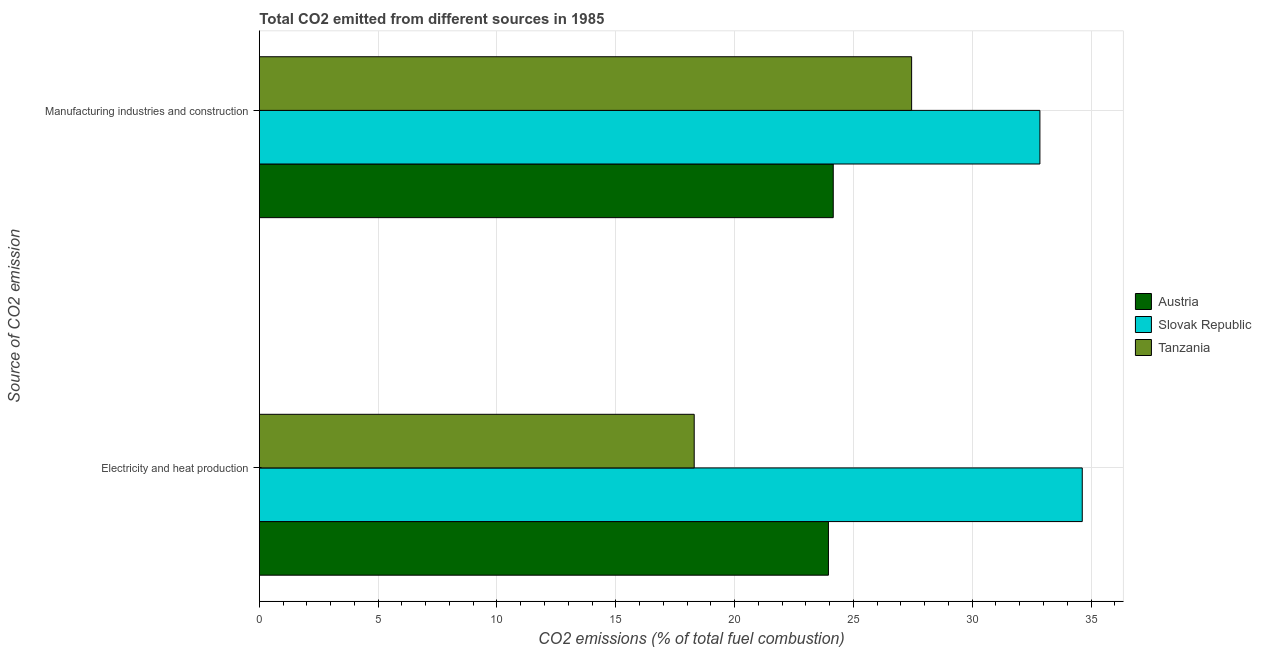How many different coloured bars are there?
Ensure brevity in your answer.  3. Are the number of bars per tick equal to the number of legend labels?
Offer a very short reply. Yes. Are the number of bars on each tick of the Y-axis equal?
Ensure brevity in your answer.  Yes. How many bars are there on the 1st tick from the top?
Offer a very short reply. 3. How many bars are there on the 2nd tick from the bottom?
Your response must be concise. 3. What is the label of the 1st group of bars from the top?
Make the answer very short. Manufacturing industries and construction. What is the co2 emissions due to manufacturing industries in Tanzania?
Your answer should be compact. 27.45. Across all countries, what is the maximum co2 emissions due to electricity and heat production?
Provide a succinct answer. 34.63. Across all countries, what is the minimum co2 emissions due to electricity and heat production?
Ensure brevity in your answer.  18.3. In which country was the co2 emissions due to electricity and heat production maximum?
Provide a short and direct response. Slovak Republic. In which country was the co2 emissions due to electricity and heat production minimum?
Your answer should be very brief. Tanzania. What is the total co2 emissions due to manufacturing industries in the graph?
Make the answer very short. 84.45. What is the difference between the co2 emissions due to electricity and heat production in Austria and that in Slovak Republic?
Offer a terse response. -10.68. What is the difference between the co2 emissions due to manufacturing industries in Tanzania and the co2 emissions due to electricity and heat production in Austria?
Make the answer very short. 3.5. What is the average co2 emissions due to electricity and heat production per country?
Offer a terse response. 25.63. What is the difference between the co2 emissions due to electricity and heat production and co2 emissions due to manufacturing industries in Slovak Republic?
Provide a short and direct response. 1.78. What is the ratio of the co2 emissions due to electricity and heat production in Slovak Republic to that in Austria?
Offer a terse response. 1.45. Is the co2 emissions due to electricity and heat production in Slovak Republic less than that in Tanzania?
Your answer should be very brief. No. In how many countries, is the co2 emissions due to electricity and heat production greater than the average co2 emissions due to electricity and heat production taken over all countries?
Offer a terse response. 1. What does the 3rd bar from the top in Manufacturing industries and construction represents?
Provide a short and direct response. Austria. What does the 3rd bar from the bottom in Manufacturing industries and construction represents?
Give a very brief answer. Tanzania. Are all the bars in the graph horizontal?
Your answer should be very brief. Yes. What is the difference between two consecutive major ticks on the X-axis?
Your response must be concise. 5. Where does the legend appear in the graph?
Offer a very short reply. Center right. How many legend labels are there?
Your answer should be compact. 3. What is the title of the graph?
Provide a short and direct response. Total CO2 emitted from different sources in 1985. Does "OECD members" appear as one of the legend labels in the graph?
Give a very brief answer. No. What is the label or title of the X-axis?
Offer a very short reply. CO2 emissions (% of total fuel combustion). What is the label or title of the Y-axis?
Ensure brevity in your answer.  Source of CO2 emission. What is the CO2 emissions (% of total fuel combustion) in Austria in Electricity and heat production?
Provide a short and direct response. 23.95. What is the CO2 emissions (% of total fuel combustion) of Slovak Republic in Electricity and heat production?
Offer a very short reply. 34.63. What is the CO2 emissions (% of total fuel combustion) of Tanzania in Electricity and heat production?
Your response must be concise. 18.3. What is the CO2 emissions (% of total fuel combustion) in Austria in Manufacturing industries and construction?
Your answer should be very brief. 24.15. What is the CO2 emissions (% of total fuel combustion) of Slovak Republic in Manufacturing industries and construction?
Your response must be concise. 32.85. What is the CO2 emissions (% of total fuel combustion) in Tanzania in Manufacturing industries and construction?
Your answer should be compact. 27.45. Across all Source of CO2 emission, what is the maximum CO2 emissions (% of total fuel combustion) in Austria?
Give a very brief answer. 24.15. Across all Source of CO2 emission, what is the maximum CO2 emissions (% of total fuel combustion) in Slovak Republic?
Your answer should be compact. 34.63. Across all Source of CO2 emission, what is the maximum CO2 emissions (% of total fuel combustion) of Tanzania?
Your response must be concise. 27.45. Across all Source of CO2 emission, what is the minimum CO2 emissions (% of total fuel combustion) of Austria?
Your answer should be compact. 23.95. Across all Source of CO2 emission, what is the minimum CO2 emissions (% of total fuel combustion) in Slovak Republic?
Offer a terse response. 32.85. Across all Source of CO2 emission, what is the minimum CO2 emissions (% of total fuel combustion) of Tanzania?
Offer a very short reply. 18.3. What is the total CO2 emissions (% of total fuel combustion) in Austria in the graph?
Provide a succinct answer. 48.1. What is the total CO2 emissions (% of total fuel combustion) of Slovak Republic in the graph?
Your response must be concise. 67.48. What is the total CO2 emissions (% of total fuel combustion) of Tanzania in the graph?
Make the answer very short. 45.75. What is the difference between the CO2 emissions (% of total fuel combustion) in Austria in Electricity and heat production and that in Manufacturing industries and construction?
Your answer should be compact. -0.2. What is the difference between the CO2 emissions (% of total fuel combustion) of Slovak Republic in Electricity and heat production and that in Manufacturing industries and construction?
Make the answer very short. 1.78. What is the difference between the CO2 emissions (% of total fuel combustion) of Tanzania in Electricity and heat production and that in Manufacturing industries and construction?
Your answer should be compact. -9.15. What is the difference between the CO2 emissions (% of total fuel combustion) in Austria in Electricity and heat production and the CO2 emissions (% of total fuel combustion) in Slovak Republic in Manufacturing industries and construction?
Offer a terse response. -8.9. What is the difference between the CO2 emissions (% of total fuel combustion) in Austria in Electricity and heat production and the CO2 emissions (% of total fuel combustion) in Tanzania in Manufacturing industries and construction?
Your answer should be very brief. -3.5. What is the difference between the CO2 emissions (% of total fuel combustion) in Slovak Republic in Electricity and heat production and the CO2 emissions (% of total fuel combustion) in Tanzania in Manufacturing industries and construction?
Keep it short and to the point. 7.18. What is the average CO2 emissions (% of total fuel combustion) of Austria per Source of CO2 emission?
Your answer should be very brief. 24.05. What is the average CO2 emissions (% of total fuel combustion) in Slovak Republic per Source of CO2 emission?
Give a very brief answer. 33.74. What is the average CO2 emissions (% of total fuel combustion) of Tanzania per Source of CO2 emission?
Your answer should be very brief. 22.88. What is the difference between the CO2 emissions (% of total fuel combustion) of Austria and CO2 emissions (% of total fuel combustion) of Slovak Republic in Electricity and heat production?
Keep it short and to the point. -10.68. What is the difference between the CO2 emissions (% of total fuel combustion) in Austria and CO2 emissions (% of total fuel combustion) in Tanzania in Electricity and heat production?
Offer a terse response. 5.65. What is the difference between the CO2 emissions (% of total fuel combustion) in Slovak Republic and CO2 emissions (% of total fuel combustion) in Tanzania in Electricity and heat production?
Offer a terse response. 16.33. What is the difference between the CO2 emissions (% of total fuel combustion) in Austria and CO2 emissions (% of total fuel combustion) in Slovak Republic in Manufacturing industries and construction?
Offer a terse response. -8.7. What is the difference between the CO2 emissions (% of total fuel combustion) of Austria and CO2 emissions (% of total fuel combustion) of Tanzania in Manufacturing industries and construction?
Your answer should be very brief. -3.3. What is the difference between the CO2 emissions (% of total fuel combustion) in Slovak Republic and CO2 emissions (% of total fuel combustion) in Tanzania in Manufacturing industries and construction?
Keep it short and to the point. 5.4. What is the ratio of the CO2 emissions (% of total fuel combustion) in Austria in Electricity and heat production to that in Manufacturing industries and construction?
Provide a short and direct response. 0.99. What is the ratio of the CO2 emissions (% of total fuel combustion) of Slovak Republic in Electricity and heat production to that in Manufacturing industries and construction?
Your response must be concise. 1.05. What is the difference between the highest and the second highest CO2 emissions (% of total fuel combustion) of Austria?
Provide a succinct answer. 0.2. What is the difference between the highest and the second highest CO2 emissions (% of total fuel combustion) in Slovak Republic?
Ensure brevity in your answer.  1.78. What is the difference between the highest and the second highest CO2 emissions (% of total fuel combustion) of Tanzania?
Offer a terse response. 9.15. What is the difference between the highest and the lowest CO2 emissions (% of total fuel combustion) in Austria?
Give a very brief answer. 0.2. What is the difference between the highest and the lowest CO2 emissions (% of total fuel combustion) in Slovak Republic?
Your response must be concise. 1.78. What is the difference between the highest and the lowest CO2 emissions (% of total fuel combustion) of Tanzania?
Provide a short and direct response. 9.15. 